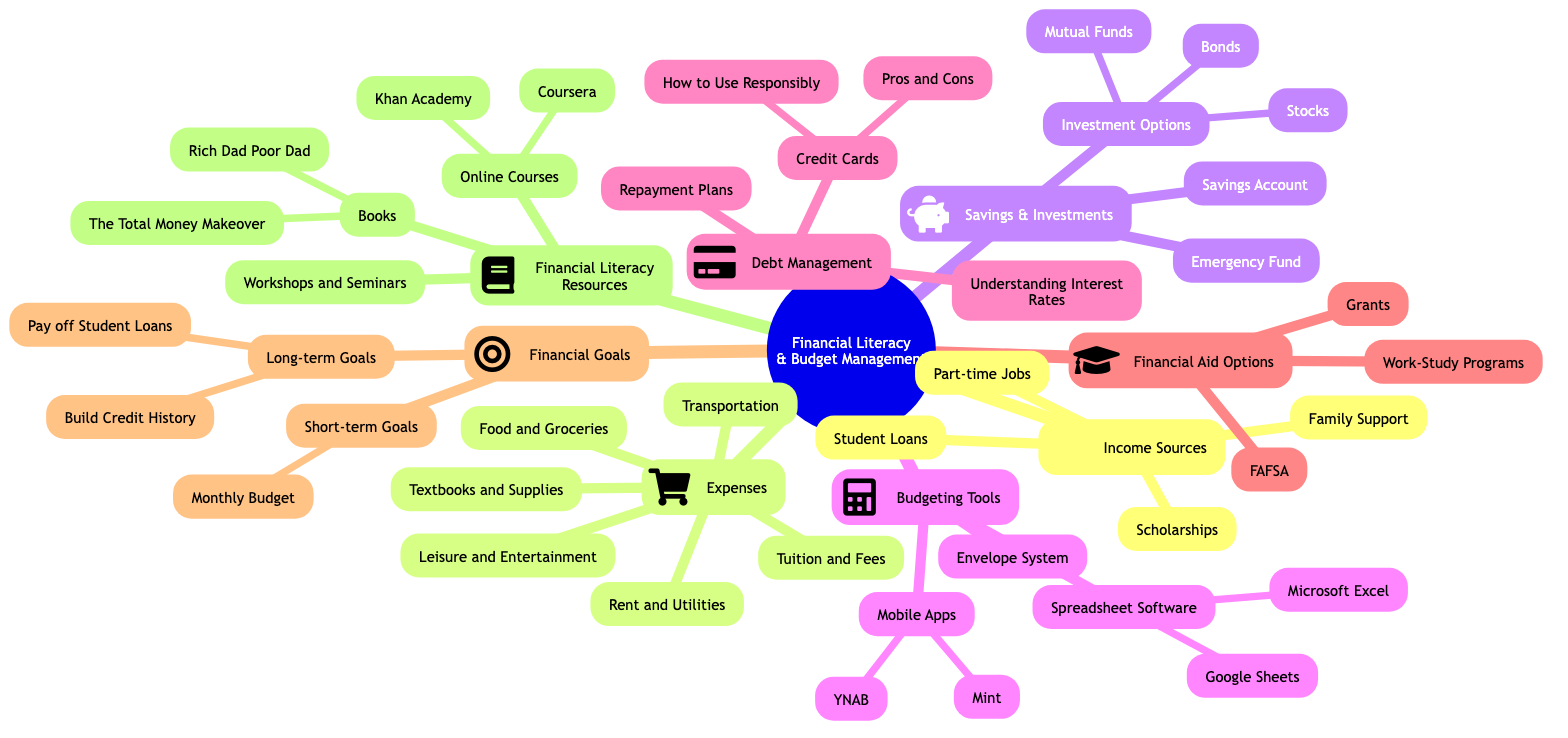What are the sources of income listed? The diagram outlines four primary sources of income under the "Income Sources" node: Scholarships, Part-time Jobs, Student Loans, and Family Support.
Answer: Scholarships, Part-time Jobs, Student Loans, Family Support How many types of expenses are mentioned? In the "Expenses" section, there are six types of expenses listed: Tuition and Fees, Textbooks and Supplies, Rent and Utilities, Food and Groceries, Transportation, and Leisure and Entertainment. Counting these gives a total of six.
Answer: 6 What budgeting tool includes mobile apps? Under the "Budgeting Tools" node, the specific tool that includes mobile apps is labeled as "Mobile Apps," which further lists Mint and YNAB (You Need a Budget).
Answer: Mobile Apps What are the long-term financial goals listed? The diagram identifies two long-term goals under the "Financial Goals" section: Pay off Student Loans and Build Credit History. This indicates that these goals focus on significant financial outcomes after a longer timeframe.
Answer: Pay off Student Loans, Build Credit History Which financial literacy resource offers online courses? The section "Financial Literacy Resources" contains the subcategory "Online Courses," which highlights Coursera and Khan Academy as specific sources for such educational material.
Answer: Online Courses What does the Envelope System refer to? The Envelope System is listed under the "Budgeting Tools" section, indicating it is a method for managing budgeted amounts of cash for different spending categories. It implies a physical or digital way to allocate funds for controlled spending.
Answer: Envelope System What is the importance of understanding interest rates in debt management? Understanding interest rates is crucial as it helps students make informed decisions about borrowing and managing their debts responsibly. This node connects with "Debt Management" to highlight its significance in financial literacy.
Answer: Understanding Interest Rates Which platform provides financial workshops and seminars? There is a node labeled "Workshops and Seminars" under "Financial Literacy Resources," indicating that this method is one way to enhance financial knowledge through in-person or virtual learning experiences.
Answer: Workshops and Seminars 